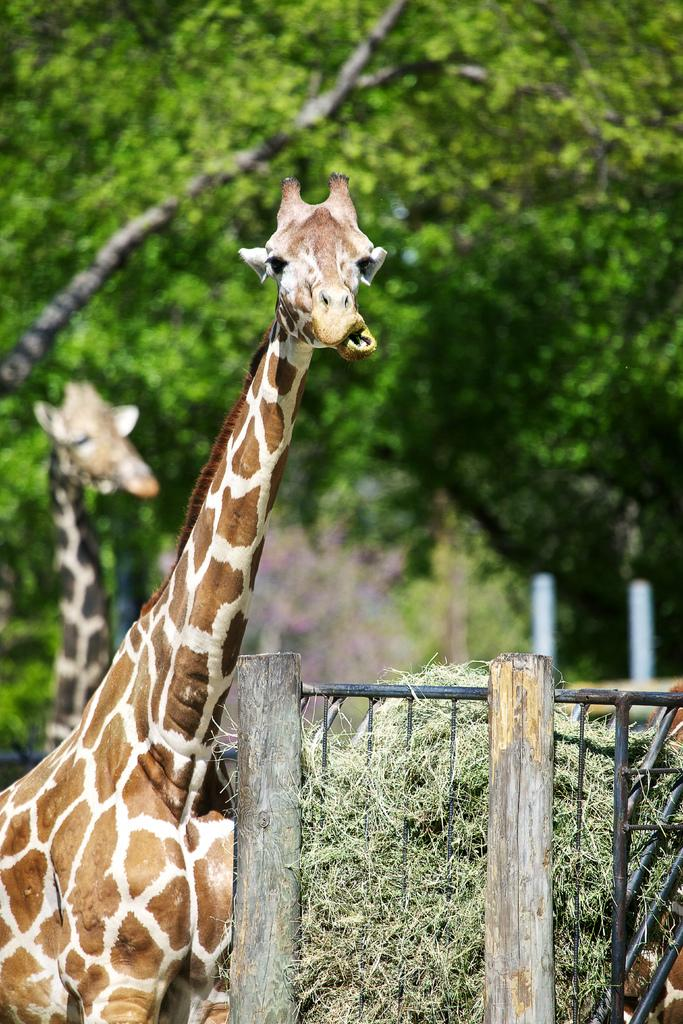What animals can be seen in the image? There are giraffes in the image. What type of vegetation is in front of the giraffes? There is grass in front of the giraffes. What kind of barrier is present in the image? There is a wooden fence in the image. What can be seen in the distance behind the giraffes? There are trees in the background of the image. How many cards are being held by the giraffes in the image? There are no cards present in the image; the giraffes are not holding any cards. 